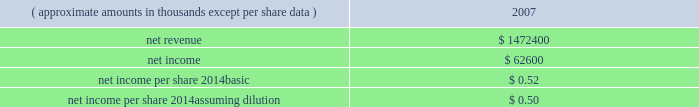Hologic , inc .
Notes to consolidated financial statements ( continued ) ( in thousands , except per share data ) failure of the company to develop new products and product enhancements on a timely basis or within budget could harm the company 2019s results of operations and financial condition .
For additional risks that may affect the company 2019s business and prospects following completion of the merger , see 201crisk factors 201d in item 1a of the company 2019s form 10-k for the year ended september 29 , 2007 .
Goodwill the preliminary purchase price allocation has resulted in goodwill of approximately $ 3895100 .
The factors contributing to the recognition of this amount of goodwill are based upon several strategic and synergistic benefits that are expected to be realized from the combination .
These benefits include the expectation that the company 2019s complementary products and technologies will create a leading women 2019s healthcare company with an enhanced presence in hospitals , private practices and healthcare organizations .
The company also expects to realize substantial synergies through the use of cytyc 2019s ob/gyn and breast surgeon sales channel to cross-sell the company 2019s existing and future products .
The merger provides the company broader channel coverage within the united states and expanded geographic reach internationally , as well as increased scale and scope for further expanding operations through product development and complementary strategic transactions .
Supplemental unaudited pro-forma information the following unaudited pro forma information presents the consolidated results of operations of the company and cytyc as if the acquisitions had occurred at the beginning of fiscal 2007 , with pro forma adjustments to give effect to amortization of intangible assets , an increase in interest expense on acquisition financing and certain other adjustments together with related tax effects: .
The $ 368200 charge for acquired in-process research and development that was a direct result of the transaction is excluded from the unaudited pro forma information above .
The unaudited pro forma results are not necessarily indicative of the results that the company would have attained had the acquisitions of cytyc occurred at the beginning of the periods presented .
Prior to the close of the merger the board of directors of both hologic and cytyc approved a modification to certain outstanding equity awards for cytyc employees .
The modification provided for the acceleration of vesting upon the close of merger for those awards that did not provide for acceleration upon a change of control as part of the original terms of the award .
This modification was made so that the company will not incur stock based compensation charges that it otherwise would have if the awards had continued to vest under their original terms .
Credit agreement on october 22 , 2007 , company and certain of its domestic subsidiaries , entered into a senior secured credit agreement with goldman sachs credit partners l.p .
And certain other lenders , ( collectively , the 201clenders 201d ) .
Pursuant to the terms and conditions of the credit agreement , the lenders have committed to provide senior secured financing in an aggregate amount of up to $ 2550000 .
As of the closing of the cytyc merger , the company borrowed $ 2350000 under the credit facilities. .
What is the estimated number of outstanding shares based in the stated eps? 
Computations: (62600 / 0.52)
Answer: 120384.61538. 